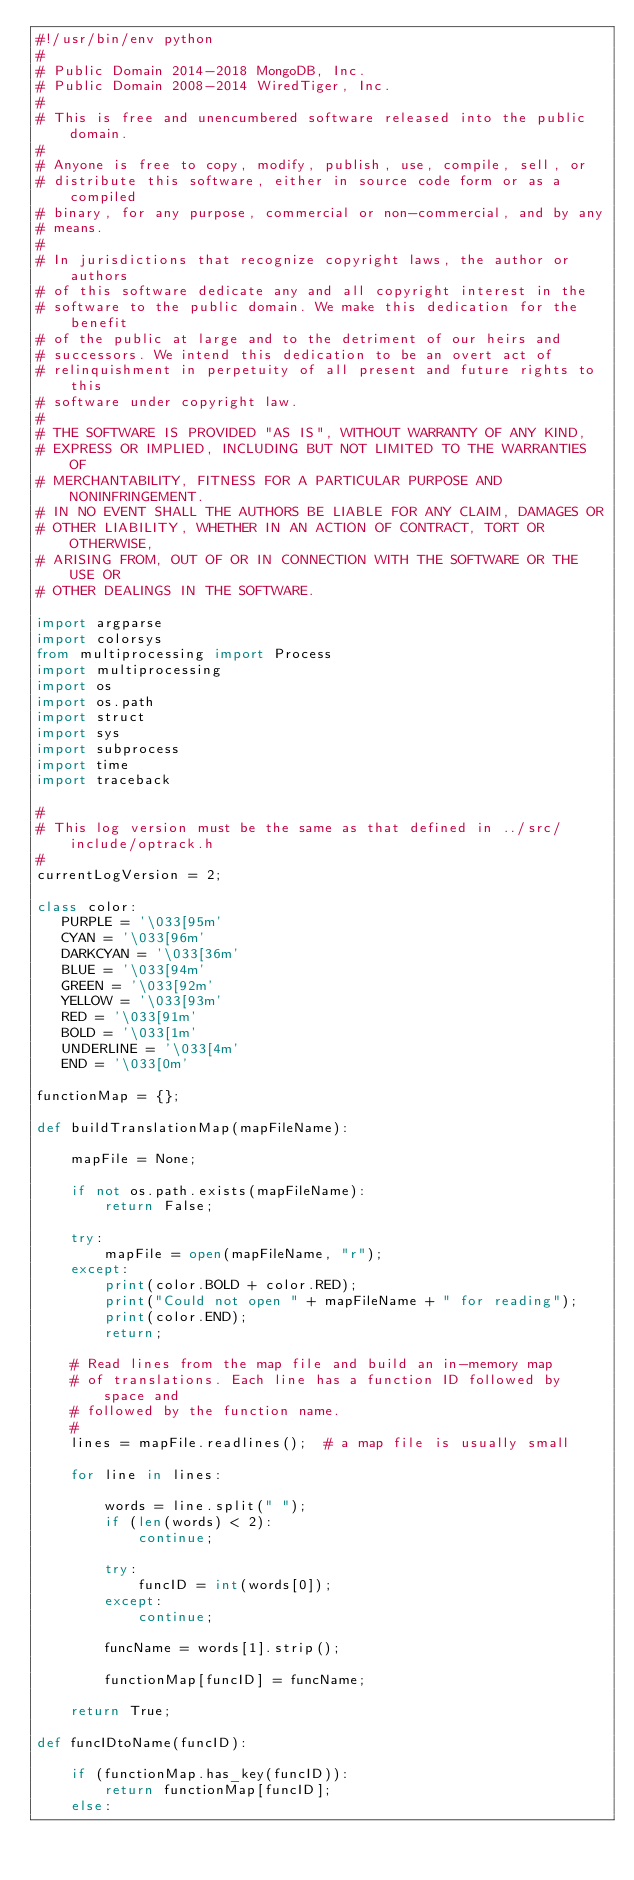<code> <loc_0><loc_0><loc_500><loc_500><_Python_>#!/usr/bin/env python
#
# Public Domain 2014-2018 MongoDB, Inc.
# Public Domain 2008-2014 WiredTiger, Inc.
#
# This is free and unencumbered software released into the public domain.
#
# Anyone is free to copy, modify, publish, use, compile, sell, or
# distribute this software, either in source code form or as a compiled
# binary, for any purpose, commercial or non-commercial, and by any
# means.
#
# In jurisdictions that recognize copyright laws, the author or authors
# of this software dedicate any and all copyright interest in the
# software to the public domain. We make this dedication for the benefit
# of the public at large and to the detriment of our heirs and
# successors. We intend this dedication to be an overt act of
# relinquishment in perpetuity of all present and future rights to this
# software under copyright law.
#
# THE SOFTWARE IS PROVIDED "AS IS", WITHOUT WARRANTY OF ANY KIND,
# EXPRESS OR IMPLIED, INCLUDING BUT NOT LIMITED TO THE WARRANTIES OF
# MERCHANTABILITY, FITNESS FOR A PARTICULAR PURPOSE AND NONINFRINGEMENT.
# IN NO EVENT SHALL THE AUTHORS BE LIABLE FOR ANY CLAIM, DAMAGES OR
# OTHER LIABILITY, WHETHER IN AN ACTION OF CONTRACT, TORT OR OTHERWISE,
# ARISING FROM, OUT OF OR IN CONNECTION WITH THE SOFTWARE OR THE USE OR
# OTHER DEALINGS IN THE SOFTWARE.

import argparse
import colorsys
from multiprocessing import Process
import multiprocessing
import os
import os.path
import struct
import sys
import subprocess
import time
import traceback

#
# This log version must be the same as that defined in ../src/include/optrack.h
#
currentLogVersion = 2;

class color:
   PURPLE = '\033[95m'
   CYAN = '\033[96m'
   DARKCYAN = '\033[36m'
   BLUE = '\033[94m'
   GREEN = '\033[92m'
   YELLOW = '\033[93m'
   RED = '\033[91m'
   BOLD = '\033[1m'
   UNDERLINE = '\033[4m'
   END = '\033[0m'

functionMap = {};

def buildTranslationMap(mapFileName):

    mapFile = None;

    if not os.path.exists(mapFileName):
        return False;

    try:
        mapFile = open(mapFileName, "r");
    except:
        print(color.BOLD + color.RED);
        print("Could not open " + mapFileName + " for reading");
        print(color.END);
        return;

    # Read lines from the map file and build an in-memory map
    # of translations. Each line has a function ID followed by space and
    # followed by the function name.
    #
    lines = mapFile.readlines();  # a map file is usually small

    for line in lines:

        words = line.split(" ");
        if (len(words) < 2):
            continue;

        try:
            funcID = int(words[0]);
        except:
            continue;

        funcName = words[1].strip();

        functionMap[funcID] = funcName;

    return True;

def funcIDtoName(funcID):

    if (functionMap.has_key(funcID)):
        return functionMap[funcID];
    else:</code> 